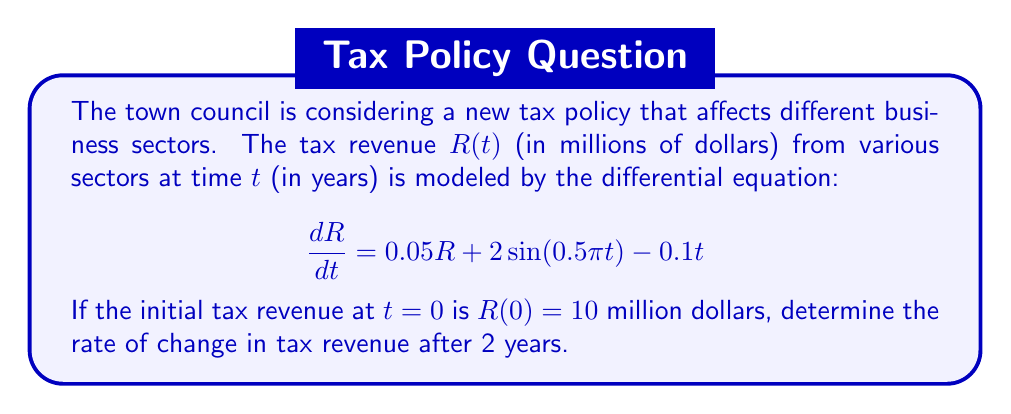Show me your answer to this math problem. To solve this problem, we need to follow these steps:

1) The given differential equation is:
   $$\frac{dR}{dt} = 0.05R + 2\sin(0.5\pi t) - 0.1t$$

2) We're asked to find the rate of change after 2 years, so we need to evaluate $\frac{dR}{dt}$ at $t=2$.

3) To do this, we need to know the value of $R$ at $t=2$. However, we're not given this information directly. We only know the initial condition $R(0) = 10$.

4) Fortunately, we don't need to solve the differential equation completely. We can simply substitute $t=2$ into the right-hand side of the equation:

   $$\left.\frac{dR}{dt}\right|_{t=2} = 0.05R(2) + 2\sin(0.5\pi \cdot 2) - 0.1 \cdot 2$$

5) Simplify:
   $$\left.\frac{dR}{dt}\right|_{t=2} = 0.05R(2) + 2\sin(\pi) - 0.2$$
   $$\left.\frac{dR}{dt}\right|_{t=2} = 0.05R(2) + 0 - 0.2$$
   $$\left.\frac{dR}{dt}\right|_{t=2} = 0.05R(2) - 0.2$$

6) We still don't know $R(2)$, but we can express the rate of change in terms of $R(2)$.

This result shows that the rate of change in tax revenue after 2 years depends on the actual revenue at that time. The rate of change will be positive if $R(2) > 4$ million dollars, and negative if $R(2) < 4$ million dollars.
Answer: $$\left.\frac{dR}{dt}\right|_{t=2} = 0.05R(2) - 0.2$$ million dollars per year 